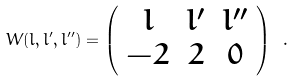Convert formula to latex. <formula><loc_0><loc_0><loc_500><loc_500>W ( l , l ^ { \prime } , l ^ { \prime \prime } ) = \left ( \begin{array} { c c c } l & l ^ { \prime } & l ^ { \prime \prime } \\ - 2 & 2 & 0 \end{array} \right ) \ .</formula> 